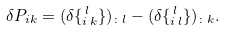Convert formula to latex. <formula><loc_0><loc_0><loc_500><loc_500>\delta P _ { i k } = ( \delta \{ ^ { \, l } _ { i \, k } \} ) _ { \colon l } - ( \delta \{ ^ { \, l } _ { i \, l } \} ) _ { \colon k } .</formula> 